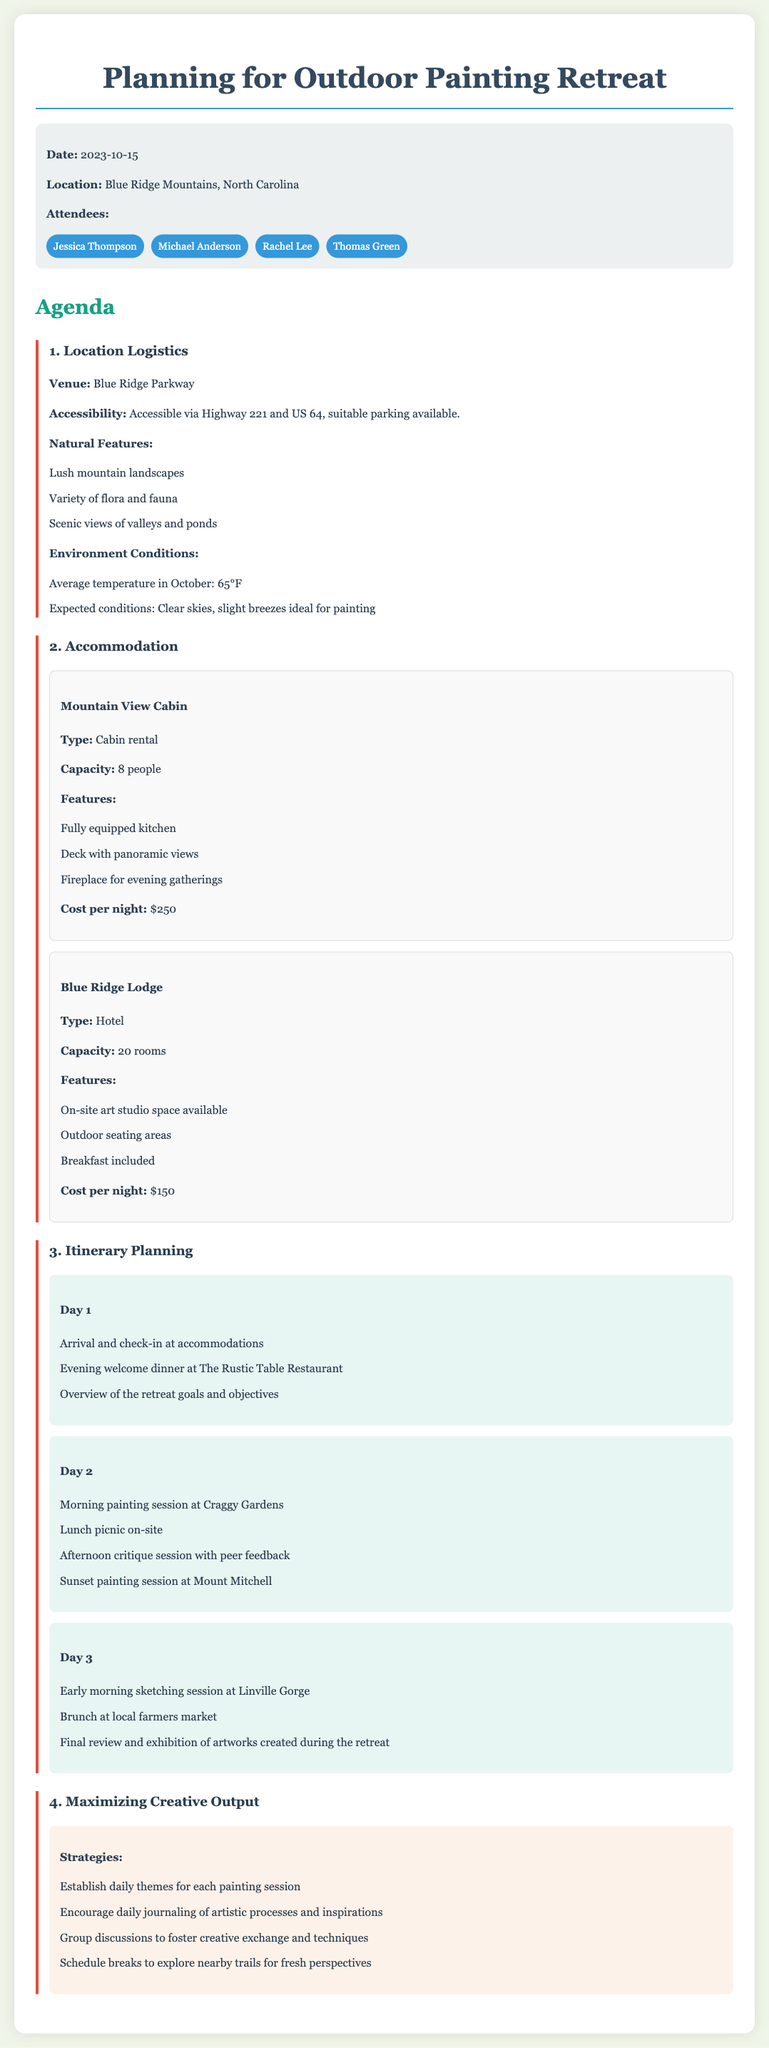What is the date of the retreat? The retreat is scheduled for October 15, 2023, as mentioned in the document.
Answer: October 15, 2023 Where is the location of the retreat? The document specifies that the location is the Blue Ridge Mountains in North Carolina.
Answer: Blue Ridge Mountains, North Carolina What type of accommodation is available at Mountain View Cabin? The document states that Mountain View Cabin is a cabin rental.
Answer: Cabin rental How many people can the Blue Ridge Lodge accommodate? The document indicates that the Blue Ridge Lodge has the capacity for 20 rooms, which suggests it can accommodate multiple guests.
Answer: 20 rooms What is the cost per night for the Mountain View Cabin? The document lists the cost for the Mountain View Cabin as 250 dollars.
Answer: $250 What is the first activity scheduled for Day 1? The document mentions that arrival and check-in at accommodations is the first activity for Day 1.
Answer: Arrival and check-in What is the strategy for maximizing creative output related to daily activities? The document suggests establishing daily themes for each painting session as one strategy to maximize creative output.
Answer: Establish daily themes What is one natural feature mentioned in the location logistics? The document lists lush mountain landscapes as one of the natural features of the retreat location.
Answer: Lush mountain landscapes What is the average temperature expected in October? The document specifies the average temperature in October to be 65 degrees Fahrenheit.
Answer: 65°F 